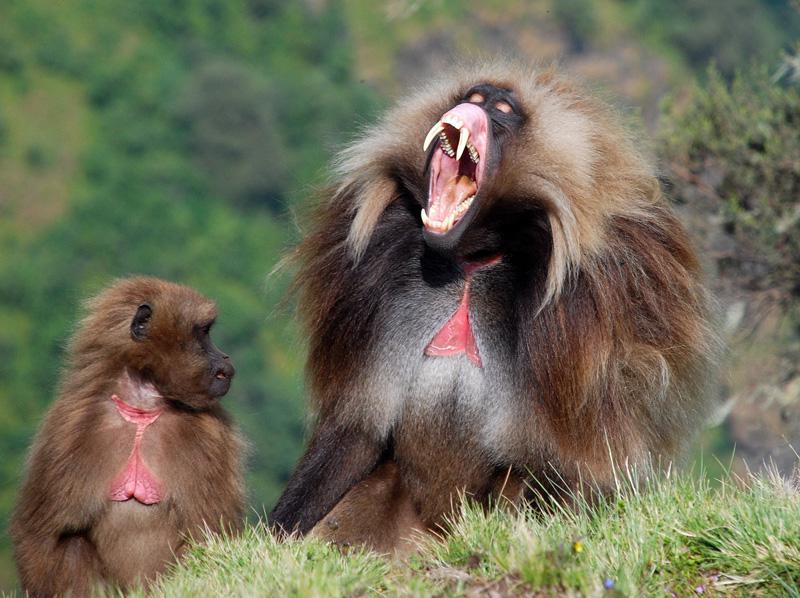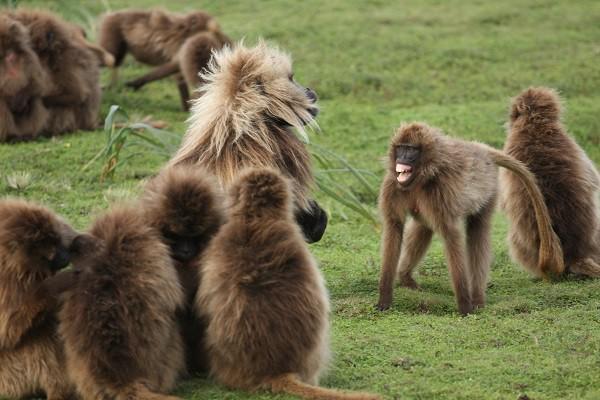The first image is the image on the left, the second image is the image on the right. Given the left and right images, does the statement "The right image contains exactly two primates." hold true? Answer yes or no. No. The first image is the image on the left, the second image is the image on the right. Given the left and right images, does the statement "A forward-facing fang-baring monkey with a lion-like mane of hair is in an image containing two animals." hold true? Answer yes or no. Yes. 